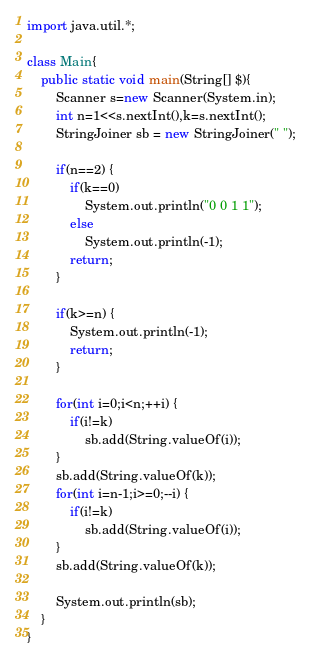Convert code to text. <code><loc_0><loc_0><loc_500><loc_500><_Java_>import java.util.*;

class Main{
	public static void main(String[] $){
		Scanner s=new Scanner(System.in);
		int n=1<<s.nextInt(),k=s.nextInt();
		StringJoiner sb = new StringJoiner(" ");

		if(n==2) {
			if(k==0)
				System.out.println("0 0 1 1");
			else
				System.out.println(-1);
			return;
		}

		if(k>=n) {
			System.out.println(-1);
			return;
		}

		for(int i=0;i<n;++i) {
			if(i!=k)
				sb.add(String.valueOf(i));
		}
		sb.add(String.valueOf(k));
		for(int i=n-1;i>=0;--i) {
			if(i!=k)
				sb.add(String.valueOf(i));
		}
		sb.add(String.valueOf(k));

		System.out.println(sb);
	}
}</code> 